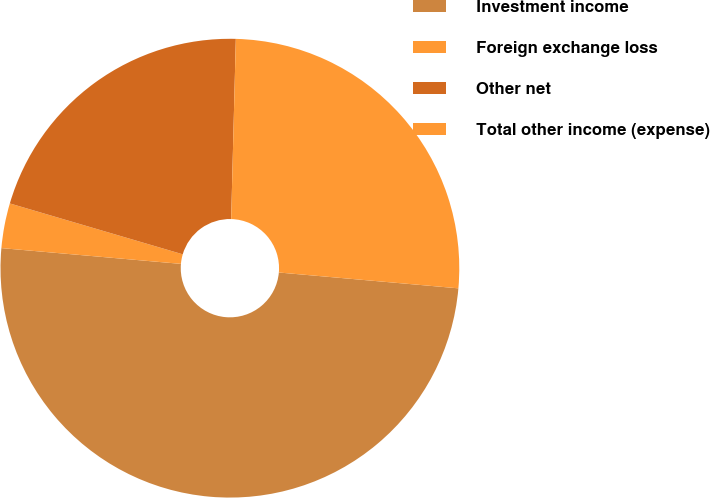Convert chart to OTSL. <chart><loc_0><loc_0><loc_500><loc_500><pie_chart><fcel>Investment income<fcel>Foreign exchange loss<fcel>Other net<fcel>Total other income (expense)<nl><fcel>50.0%<fcel>3.16%<fcel>20.86%<fcel>25.99%<nl></chart> 